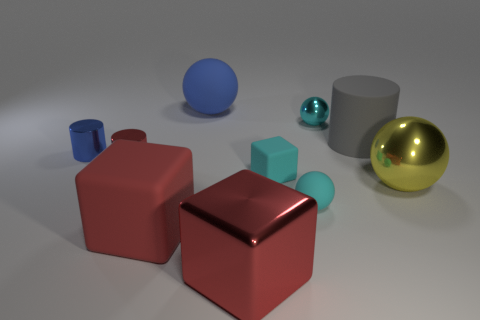What is the shape of the thing that is the same color as the large matte sphere?
Your response must be concise. Cylinder. What number of tiny cylinders are on the right side of the large matte sphere?
Your answer should be compact. 0. What is the size of the matte cube that is in front of the matte sphere in front of the shiny cylinder on the left side of the tiny red metal object?
Your response must be concise. Large. There is a red metal thing behind the red object in front of the red matte object; are there any cyan matte balls behind it?
Give a very brief answer. No. Is the number of small blue shiny cylinders greater than the number of small green metal balls?
Offer a terse response. Yes. What color is the large sphere in front of the large gray cylinder?
Keep it short and to the point. Yellow. Are there more large rubber things behind the large blue matte ball than small gray shiny spheres?
Your response must be concise. No. Is the yellow ball made of the same material as the blue sphere?
Give a very brief answer. No. How many other things are there of the same shape as the yellow thing?
Give a very brief answer. 3. Is there anything else that is the same material as the big gray cylinder?
Make the answer very short. Yes. 